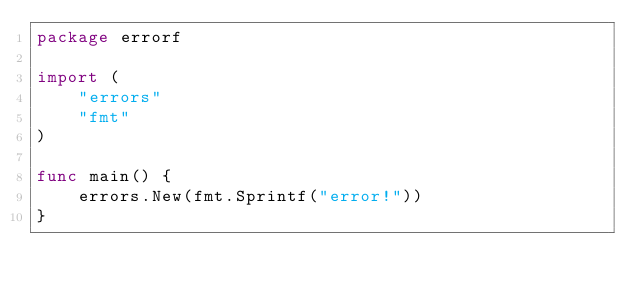Convert code to text. <code><loc_0><loc_0><loc_500><loc_500><_Go_>package errorf

import (
	"errors"
	"fmt"
)

func main() {
	errors.New(fmt.Sprintf("error!"))
}
</code> 